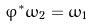Convert formula to latex. <formula><loc_0><loc_0><loc_500><loc_500>\varphi ^ { * } \omega _ { 2 } = \omega _ { 1 }</formula> 